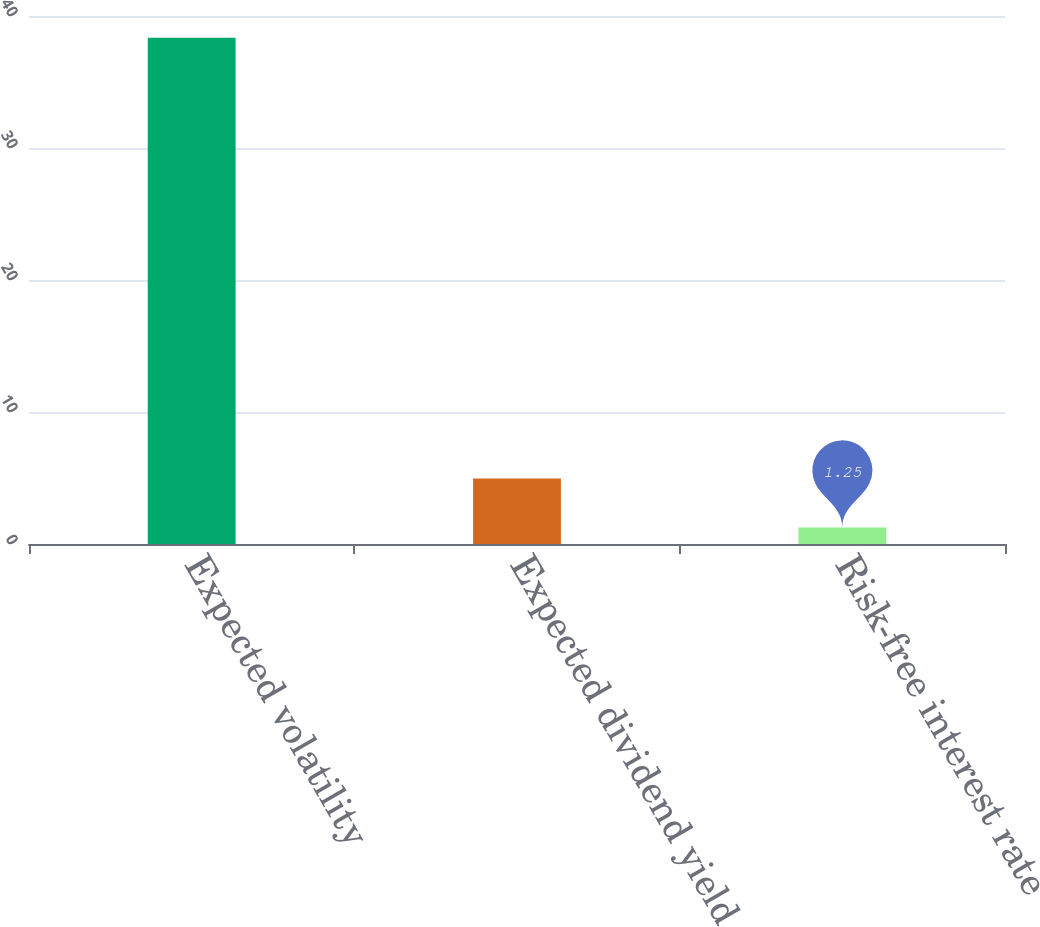Convert chart to OTSL. <chart><loc_0><loc_0><loc_500><loc_500><bar_chart><fcel>Expected volatility<fcel>Expected dividend yield<fcel>Risk-free interest rate<nl><fcel>38.36<fcel>4.96<fcel>1.25<nl></chart> 